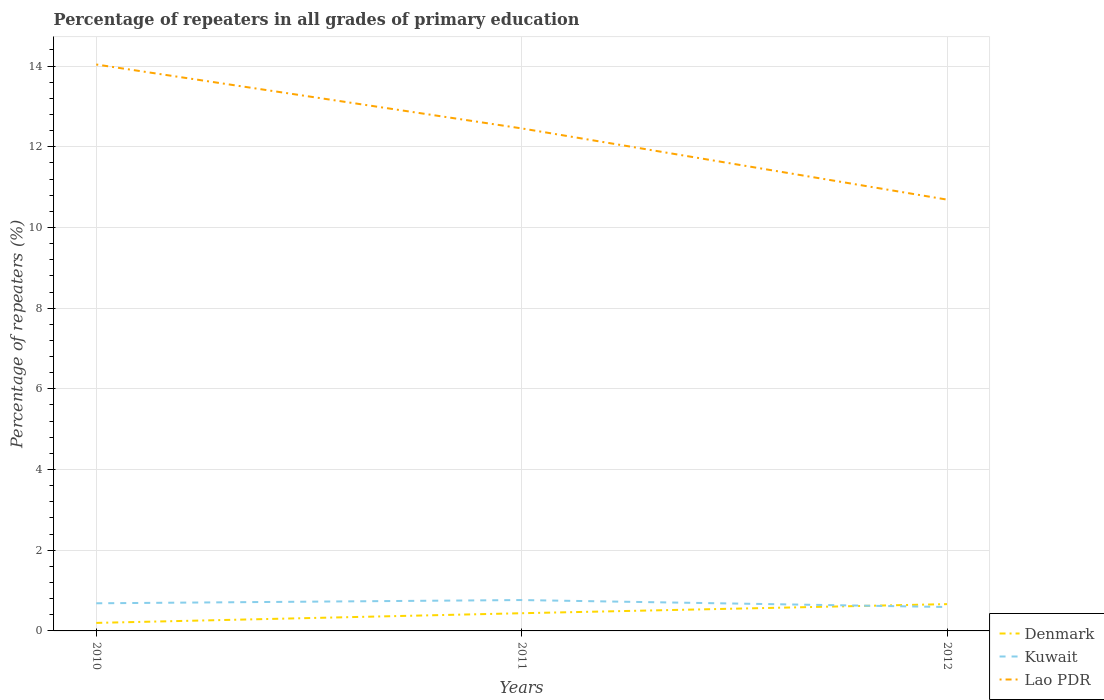How many different coloured lines are there?
Your answer should be compact. 3. Across all years, what is the maximum percentage of repeaters in Kuwait?
Your answer should be very brief. 0.59. What is the total percentage of repeaters in Lao PDR in the graph?
Give a very brief answer. 3.35. What is the difference between the highest and the second highest percentage of repeaters in Lao PDR?
Your answer should be very brief. 3.35. Is the percentage of repeaters in Kuwait strictly greater than the percentage of repeaters in Lao PDR over the years?
Provide a succinct answer. Yes. How many lines are there?
Ensure brevity in your answer.  3. What is the difference between two consecutive major ticks on the Y-axis?
Your answer should be compact. 2. Does the graph contain any zero values?
Offer a terse response. No. How many legend labels are there?
Provide a succinct answer. 3. What is the title of the graph?
Keep it short and to the point. Percentage of repeaters in all grades of primary education. Does "Channel Islands" appear as one of the legend labels in the graph?
Keep it short and to the point. No. What is the label or title of the X-axis?
Provide a short and direct response. Years. What is the label or title of the Y-axis?
Keep it short and to the point. Percentage of repeaters (%). What is the Percentage of repeaters (%) of Denmark in 2010?
Your answer should be compact. 0.2. What is the Percentage of repeaters (%) in Kuwait in 2010?
Provide a succinct answer. 0.68. What is the Percentage of repeaters (%) of Lao PDR in 2010?
Ensure brevity in your answer.  14.04. What is the Percentage of repeaters (%) of Denmark in 2011?
Your response must be concise. 0.44. What is the Percentage of repeaters (%) in Kuwait in 2011?
Your answer should be compact. 0.77. What is the Percentage of repeaters (%) in Lao PDR in 2011?
Your answer should be compact. 12.46. What is the Percentage of repeaters (%) of Denmark in 2012?
Provide a succinct answer. 0.66. What is the Percentage of repeaters (%) in Kuwait in 2012?
Give a very brief answer. 0.59. What is the Percentage of repeaters (%) of Lao PDR in 2012?
Provide a succinct answer. 10.69. Across all years, what is the maximum Percentage of repeaters (%) of Denmark?
Offer a very short reply. 0.66. Across all years, what is the maximum Percentage of repeaters (%) of Kuwait?
Offer a very short reply. 0.77. Across all years, what is the maximum Percentage of repeaters (%) in Lao PDR?
Your answer should be very brief. 14.04. Across all years, what is the minimum Percentage of repeaters (%) in Denmark?
Your answer should be very brief. 0.2. Across all years, what is the minimum Percentage of repeaters (%) of Kuwait?
Your answer should be compact. 0.59. Across all years, what is the minimum Percentage of repeaters (%) in Lao PDR?
Ensure brevity in your answer.  10.69. What is the total Percentage of repeaters (%) of Denmark in the graph?
Keep it short and to the point. 1.3. What is the total Percentage of repeaters (%) of Kuwait in the graph?
Keep it short and to the point. 2.04. What is the total Percentage of repeaters (%) of Lao PDR in the graph?
Provide a short and direct response. 37.19. What is the difference between the Percentage of repeaters (%) of Denmark in 2010 and that in 2011?
Offer a terse response. -0.24. What is the difference between the Percentage of repeaters (%) of Kuwait in 2010 and that in 2011?
Give a very brief answer. -0.08. What is the difference between the Percentage of repeaters (%) in Lao PDR in 2010 and that in 2011?
Your answer should be compact. 1.58. What is the difference between the Percentage of repeaters (%) in Denmark in 2010 and that in 2012?
Your answer should be very brief. -0.47. What is the difference between the Percentage of repeaters (%) of Kuwait in 2010 and that in 2012?
Provide a short and direct response. 0.09. What is the difference between the Percentage of repeaters (%) of Lao PDR in 2010 and that in 2012?
Your answer should be compact. 3.35. What is the difference between the Percentage of repeaters (%) in Denmark in 2011 and that in 2012?
Keep it short and to the point. -0.23. What is the difference between the Percentage of repeaters (%) of Kuwait in 2011 and that in 2012?
Give a very brief answer. 0.17. What is the difference between the Percentage of repeaters (%) in Lao PDR in 2011 and that in 2012?
Offer a terse response. 1.77. What is the difference between the Percentage of repeaters (%) of Denmark in 2010 and the Percentage of repeaters (%) of Kuwait in 2011?
Your answer should be compact. -0.57. What is the difference between the Percentage of repeaters (%) in Denmark in 2010 and the Percentage of repeaters (%) in Lao PDR in 2011?
Provide a short and direct response. -12.26. What is the difference between the Percentage of repeaters (%) of Kuwait in 2010 and the Percentage of repeaters (%) of Lao PDR in 2011?
Keep it short and to the point. -11.77. What is the difference between the Percentage of repeaters (%) of Denmark in 2010 and the Percentage of repeaters (%) of Kuwait in 2012?
Your response must be concise. -0.39. What is the difference between the Percentage of repeaters (%) of Denmark in 2010 and the Percentage of repeaters (%) of Lao PDR in 2012?
Give a very brief answer. -10.49. What is the difference between the Percentage of repeaters (%) in Kuwait in 2010 and the Percentage of repeaters (%) in Lao PDR in 2012?
Offer a terse response. -10.01. What is the difference between the Percentage of repeaters (%) of Denmark in 2011 and the Percentage of repeaters (%) of Kuwait in 2012?
Provide a short and direct response. -0.15. What is the difference between the Percentage of repeaters (%) in Denmark in 2011 and the Percentage of repeaters (%) in Lao PDR in 2012?
Give a very brief answer. -10.25. What is the difference between the Percentage of repeaters (%) in Kuwait in 2011 and the Percentage of repeaters (%) in Lao PDR in 2012?
Provide a short and direct response. -9.93. What is the average Percentage of repeaters (%) in Denmark per year?
Make the answer very short. 0.43. What is the average Percentage of repeaters (%) of Kuwait per year?
Give a very brief answer. 0.68. What is the average Percentage of repeaters (%) in Lao PDR per year?
Ensure brevity in your answer.  12.4. In the year 2010, what is the difference between the Percentage of repeaters (%) of Denmark and Percentage of repeaters (%) of Kuwait?
Keep it short and to the point. -0.49. In the year 2010, what is the difference between the Percentage of repeaters (%) in Denmark and Percentage of repeaters (%) in Lao PDR?
Provide a short and direct response. -13.84. In the year 2010, what is the difference between the Percentage of repeaters (%) of Kuwait and Percentage of repeaters (%) of Lao PDR?
Give a very brief answer. -13.35. In the year 2011, what is the difference between the Percentage of repeaters (%) in Denmark and Percentage of repeaters (%) in Kuwait?
Offer a terse response. -0.33. In the year 2011, what is the difference between the Percentage of repeaters (%) in Denmark and Percentage of repeaters (%) in Lao PDR?
Keep it short and to the point. -12.02. In the year 2011, what is the difference between the Percentage of repeaters (%) of Kuwait and Percentage of repeaters (%) of Lao PDR?
Ensure brevity in your answer.  -11.69. In the year 2012, what is the difference between the Percentage of repeaters (%) of Denmark and Percentage of repeaters (%) of Kuwait?
Make the answer very short. 0.07. In the year 2012, what is the difference between the Percentage of repeaters (%) in Denmark and Percentage of repeaters (%) in Lao PDR?
Provide a succinct answer. -10.03. In the year 2012, what is the difference between the Percentage of repeaters (%) of Kuwait and Percentage of repeaters (%) of Lao PDR?
Provide a succinct answer. -10.1. What is the ratio of the Percentage of repeaters (%) in Denmark in 2010 to that in 2011?
Provide a short and direct response. 0.45. What is the ratio of the Percentage of repeaters (%) in Kuwait in 2010 to that in 2011?
Offer a terse response. 0.9. What is the ratio of the Percentage of repeaters (%) in Lao PDR in 2010 to that in 2011?
Provide a succinct answer. 1.13. What is the ratio of the Percentage of repeaters (%) of Denmark in 2010 to that in 2012?
Ensure brevity in your answer.  0.3. What is the ratio of the Percentage of repeaters (%) in Kuwait in 2010 to that in 2012?
Ensure brevity in your answer.  1.16. What is the ratio of the Percentage of repeaters (%) of Lao PDR in 2010 to that in 2012?
Offer a very short reply. 1.31. What is the ratio of the Percentage of repeaters (%) of Denmark in 2011 to that in 2012?
Your answer should be very brief. 0.66. What is the ratio of the Percentage of repeaters (%) of Kuwait in 2011 to that in 2012?
Provide a succinct answer. 1.29. What is the ratio of the Percentage of repeaters (%) in Lao PDR in 2011 to that in 2012?
Provide a succinct answer. 1.17. What is the difference between the highest and the second highest Percentage of repeaters (%) of Denmark?
Offer a very short reply. 0.23. What is the difference between the highest and the second highest Percentage of repeaters (%) of Kuwait?
Your answer should be very brief. 0.08. What is the difference between the highest and the second highest Percentage of repeaters (%) of Lao PDR?
Provide a succinct answer. 1.58. What is the difference between the highest and the lowest Percentage of repeaters (%) of Denmark?
Offer a terse response. 0.47. What is the difference between the highest and the lowest Percentage of repeaters (%) in Kuwait?
Give a very brief answer. 0.17. What is the difference between the highest and the lowest Percentage of repeaters (%) in Lao PDR?
Keep it short and to the point. 3.35. 